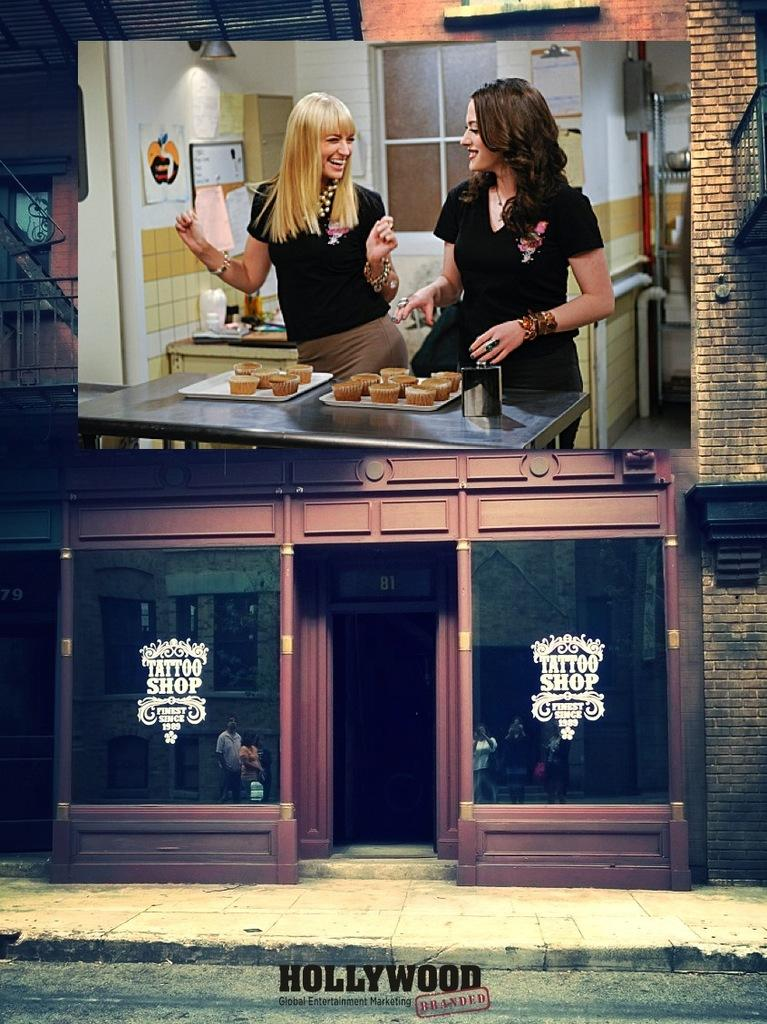What is on the store in the image? There is a screen on the store in the image. How many people are in the image? There are two women standing in the image. What is the facial expression of the women? The women are smiling. What can be seen on the table in the image? There is a table with food on it in the image. What type of cheese can be seen on the table in the image? There is no cheese visible on the table in the image. How does the key unlock the screen on the store in the image? There is no key mentioned in the image, and the screen is not described as being locked. 